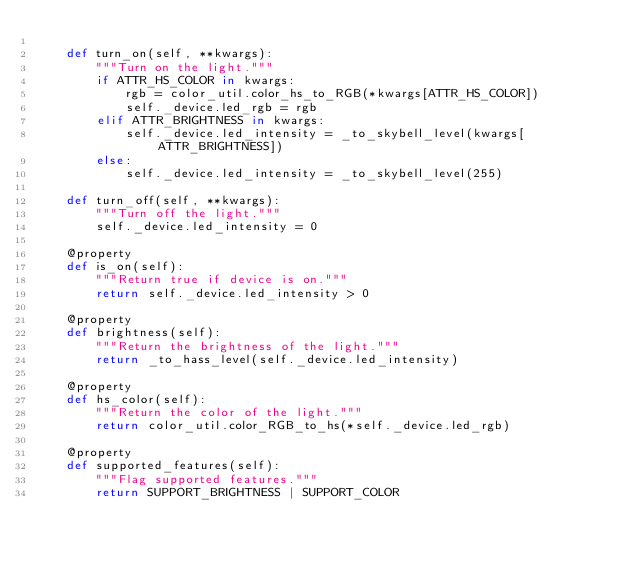<code> <loc_0><loc_0><loc_500><loc_500><_Python_>
    def turn_on(self, **kwargs):
        """Turn on the light."""
        if ATTR_HS_COLOR in kwargs:
            rgb = color_util.color_hs_to_RGB(*kwargs[ATTR_HS_COLOR])
            self._device.led_rgb = rgb
        elif ATTR_BRIGHTNESS in kwargs:
            self._device.led_intensity = _to_skybell_level(kwargs[ATTR_BRIGHTNESS])
        else:
            self._device.led_intensity = _to_skybell_level(255)

    def turn_off(self, **kwargs):
        """Turn off the light."""
        self._device.led_intensity = 0

    @property
    def is_on(self):
        """Return true if device is on."""
        return self._device.led_intensity > 0

    @property
    def brightness(self):
        """Return the brightness of the light."""
        return _to_hass_level(self._device.led_intensity)

    @property
    def hs_color(self):
        """Return the color of the light."""
        return color_util.color_RGB_to_hs(*self._device.led_rgb)

    @property
    def supported_features(self):
        """Flag supported features."""
        return SUPPORT_BRIGHTNESS | SUPPORT_COLOR
</code> 